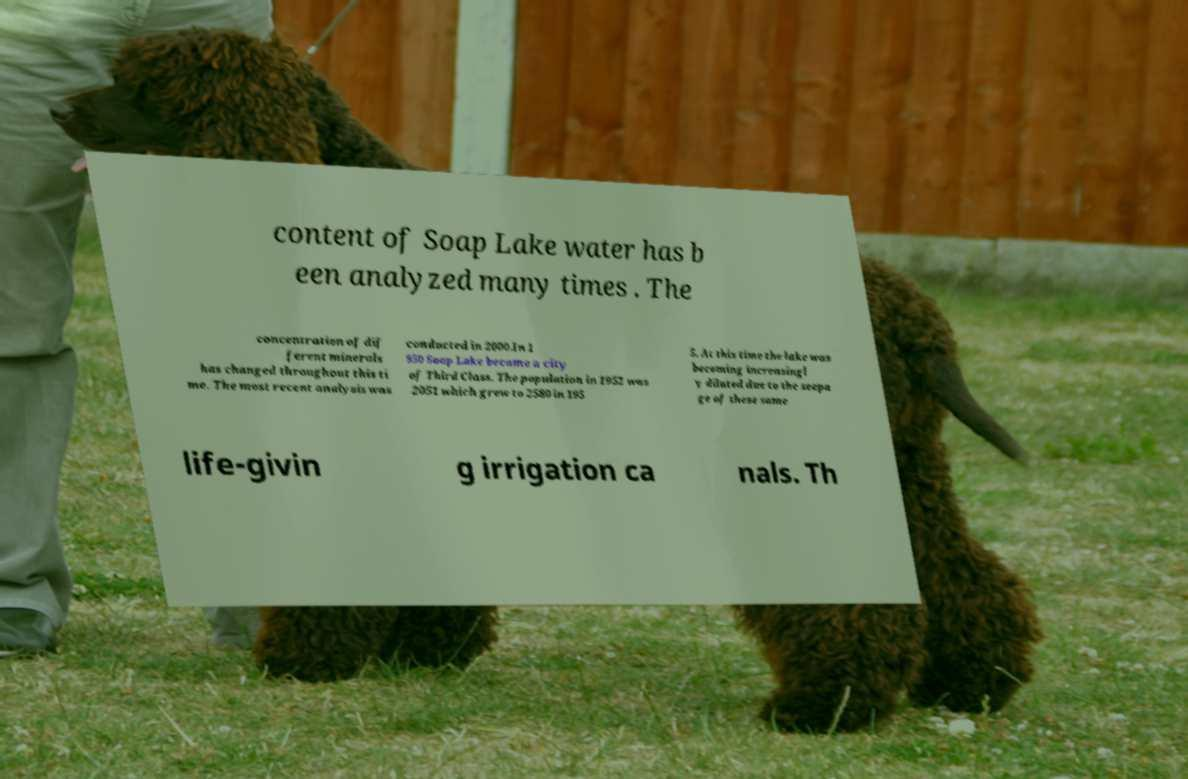Can you accurately transcribe the text from the provided image for me? content of Soap Lake water has b een analyzed many times . The concentration of dif ferent minerals has changed throughout this ti me. The most recent analysis was conducted in 2000.In 1 950 Soap Lake became a city of Third Class. The population in 1952 was 2051 which grew to 2580 in 195 5. At this time the lake was becoming increasingl y diluted due to the seepa ge of these same life-givin g irrigation ca nals. Th 